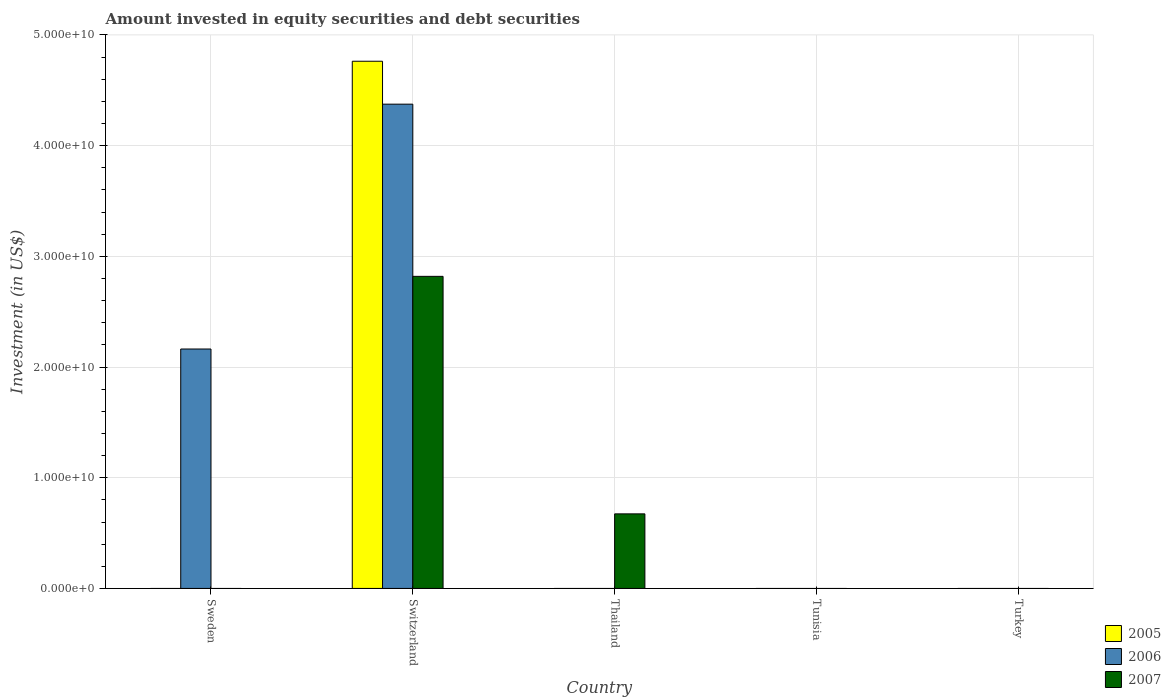Are the number of bars per tick equal to the number of legend labels?
Make the answer very short. No. Are the number of bars on each tick of the X-axis equal?
Give a very brief answer. No. What is the label of the 4th group of bars from the left?
Your answer should be compact. Tunisia. Across all countries, what is the maximum amount invested in equity securities and debt securities in 2007?
Give a very brief answer. 2.82e+1. In which country was the amount invested in equity securities and debt securities in 2005 maximum?
Keep it short and to the point. Switzerland. What is the total amount invested in equity securities and debt securities in 2006 in the graph?
Provide a succinct answer. 6.54e+1. What is the difference between the amount invested in equity securities and debt securities in 2007 in Switzerland and that in Thailand?
Ensure brevity in your answer.  2.15e+1. What is the difference between the amount invested in equity securities and debt securities in 2007 in Switzerland and the amount invested in equity securities and debt securities in 2006 in Thailand?
Provide a succinct answer. 2.82e+1. What is the average amount invested in equity securities and debt securities in 2005 per country?
Offer a terse response. 9.53e+09. What is the difference between the amount invested in equity securities and debt securities of/in 2005 and amount invested in equity securities and debt securities of/in 2007 in Switzerland?
Provide a succinct answer. 1.94e+1. In how many countries, is the amount invested in equity securities and debt securities in 2006 greater than 38000000000 US$?
Ensure brevity in your answer.  1. Is the amount invested in equity securities and debt securities in 2006 in Sweden less than that in Switzerland?
Your response must be concise. Yes. What is the difference between the highest and the lowest amount invested in equity securities and debt securities in 2006?
Your answer should be compact. 4.37e+1. In how many countries, is the amount invested in equity securities and debt securities in 2005 greater than the average amount invested in equity securities and debt securities in 2005 taken over all countries?
Make the answer very short. 1. How many bars are there?
Your answer should be very brief. 5. What is the difference between two consecutive major ticks on the Y-axis?
Ensure brevity in your answer.  1.00e+1. Are the values on the major ticks of Y-axis written in scientific E-notation?
Your response must be concise. Yes. Does the graph contain any zero values?
Your answer should be very brief. Yes. Does the graph contain grids?
Ensure brevity in your answer.  Yes. What is the title of the graph?
Keep it short and to the point. Amount invested in equity securities and debt securities. Does "1963" appear as one of the legend labels in the graph?
Offer a very short reply. No. What is the label or title of the X-axis?
Offer a very short reply. Country. What is the label or title of the Y-axis?
Provide a short and direct response. Investment (in US$). What is the Investment (in US$) in 2006 in Sweden?
Provide a short and direct response. 2.16e+1. What is the Investment (in US$) in 2007 in Sweden?
Provide a succinct answer. 0. What is the Investment (in US$) in 2005 in Switzerland?
Provide a succinct answer. 4.76e+1. What is the Investment (in US$) of 2006 in Switzerland?
Ensure brevity in your answer.  4.37e+1. What is the Investment (in US$) in 2007 in Switzerland?
Your answer should be compact. 2.82e+1. What is the Investment (in US$) in 2007 in Thailand?
Provide a succinct answer. 6.74e+09. What is the Investment (in US$) of 2005 in Tunisia?
Ensure brevity in your answer.  0. What is the Investment (in US$) in 2007 in Tunisia?
Provide a short and direct response. 0. What is the Investment (in US$) in 2006 in Turkey?
Your response must be concise. 0. Across all countries, what is the maximum Investment (in US$) of 2005?
Ensure brevity in your answer.  4.76e+1. Across all countries, what is the maximum Investment (in US$) in 2006?
Your response must be concise. 4.37e+1. Across all countries, what is the maximum Investment (in US$) of 2007?
Ensure brevity in your answer.  2.82e+1. Across all countries, what is the minimum Investment (in US$) of 2005?
Provide a short and direct response. 0. Across all countries, what is the minimum Investment (in US$) of 2006?
Provide a succinct answer. 0. What is the total Investment (in US$) of 2005 in the graph?
Your answer should be very brief. 4.76e+1. What is the total Investment (in US$) of 2006 in the graph?
Make the answer very short. 6.54e+1. What is the total Investment (in US$) of 2007 in the graph?
Offer a terse response. 3.49e+1. What is the difference between the Investment (in US$) in 2006 in Sweden and that in Switzerland?
Keep it short and to the point. -2.21e+1. What is the difference between the Investment (in US$) in 2007 in Switzerland and that in Thailand?
Ensure brevity in your answer.  2.15e+1. What is the difference between the Investment (in US$) of 2006 in Sweden and the Investment (in US$) of 2007 in Switzerland?
Give a very brief answer. -6.56e+09. What is the difference between the Investment (in US$) of 2006 in Sweden and the Investment (in US$) of 2007 in Thailand?
Your answer should be very brief. 1.49e+1. What is the difference between the Investment (in US$) in 2005 in Switzerland and the Investment (in US$) in 2007 in Thailand?
Provide a succinct answer. 4.09e+1. What is the difference between the Investment (in US$) in 2006 in Switzerland and the Investment (in US$) in 2007 in Thailand?
Ensure brevity in your answer.  3.70e+1. What is the average Investment (in US$) in 2005 per country?
Your answer should be very brief. 9.53e+09. What is the average Investment (in US$) in 2006 per country?
Your answer should be very brief. 1.31e+1. What is the average Investment (in US$) in 2007 per country?
Your answer should be very brief. 6.99e+09. What is the difference between the Investment (in US$) in 2005 and Investment (in US$) in 2006 in Switzerland?
Give a very brief answer. 3.88e+09. What is the difference between the Investment (in US$) of 2005 and Investment (in US$) of 2007 in Switzerland?
Offer a terse response. 1.94e+1. What is the difference between the Investment (in US$) of 2006 and Investment (in US$) of 2007 in Switzerland?
Make the answer very short. 1.56e+1. What is the ratio of the Investment (in US$) of 2006 in Sweden to that in Switzerland?
Keep it short and to the point. 0.49. What is the ratio of the Investment (in US$) of 2007 in Switzerland to that in Thailand?
Ensure brevity in your answer.  4.19. What is the difference between the highest and the lowest Investment (in US$) of 2005?
Give a very brief answer. 4.76e+1. What is the difference between the highest and the lowest Investment (in US$) of 2006?
Your answer should be compact. 4.37e+1. What is the difference between the highest and the lowest Investment (in US$) in 2007?
Provide a succinct answer. 2.82e+1. 